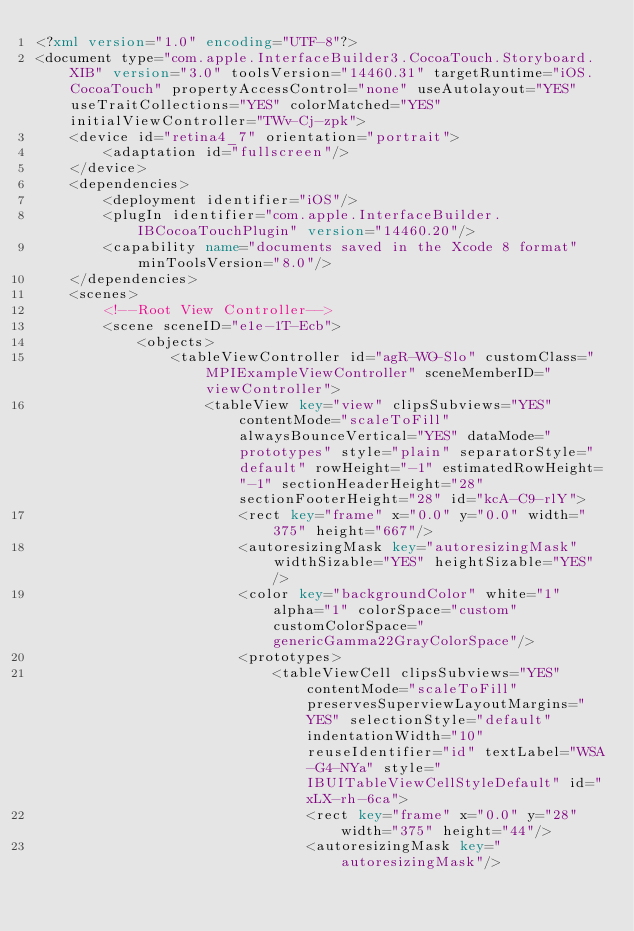<code> <loc_0><loc_0><loc_500><loc_500><_XML_><?xml version="1.0" encoding="UTF-8"?>
<document type="com.apple.InterfaceBuilder3.CocoaTouch.Storyboard.XIB" version="3.0" toolsVersion="14460.31" targetRuntime="iOS.CocoaTouch" propertyAccessControl="none" useAutolayout="YES" useTraitCollections="YES" colorMatched="YES" initialViewController="TWv-Cj-zpk">
    <device id="retina4_7" orientation="portrait">
        <adaptation id="fullscreen"/>
    </device>
    <dependencies>
        <deployment identifier="iOS"/>
        <plugIn identifier="com.apple.InterfaceBuilder.IBCocoaTouchPlugin" version="14460.20"/>
        <capability name="documents saved in the Xcode 8 format" minToolsVersion="8.0"/>
    </dependencies>
    <scenes>
        <!--Root View Controller-->
        <scene sceneID="e1e-1T-Ecb">
            <objects>
                <tableViewController id="agR-WO-Slo" customClass="MPIExampleViewController" sceneMemberID="viewController">
                    <tableView key="view" clipsSubviews="YES" contentMode="scaleToFill" alwaysBounceVertical="YES" dataMode="prototypes" style="plain" separatorStyle="default" rowHeight="-1" estimatedRowHeight="-1" sectionHeaderHeight="28" sectionFooterHeight="28" id="kcA-C9-rlY">
                        <rect key="frame" x="0.0" y="0.0" width="375" height="667"/>
                        <autoresizingMask key="autoresizingMask" widthSizable="YES" heightSizable="YES"/>
                        <color key="backgroundColor" white="1" alpha="1" colorSpace="custom" customColorSpace="genericGamma22GrayColorSpace"/>
                        <prototypes>
                            <tableViewCell clipsSubviews="YES" contentMode="scaleToFill" preservesSuperviewLayoutMargins="YES" selectionStyle="default" indentationWidth="10" reuseIdentifier="id" textLabel="WSA-G4-NYa" style="IBUITableViewCellStyleDefault" id="xLX-rh-6ca">
                                <rect key="frame" x="0.0" y="28" width="375" height="44"/>
                                <autoresizingMask key="autoresizingMask"/></code> 